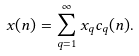Convert formula to latex. <formula><loc_0><loc_0><loc_500><loc_500>x ( n ) = \sum _ { q = 1 } ^ { \infty } x _ { q } c _ { q } ( n ) .</formula> 